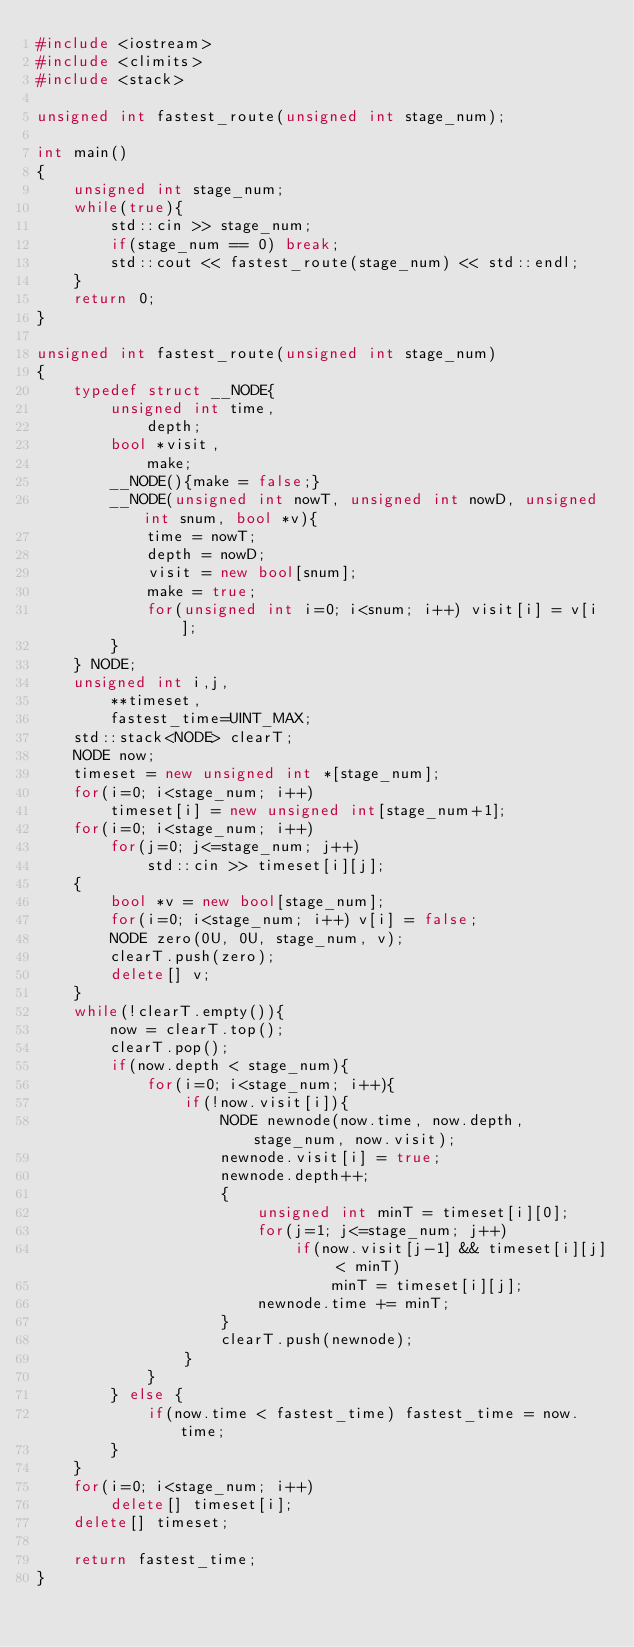Convert code to text. <code><loc_0><loc_0><loc_500><loc_500><_C++_>#include <iostream>
#include <climits>
#include <stack>

unsigned int fastest_route(unsigned int stage_num);

int main()
{
	unsigned int stage_num;
	while(true){
		std::cin >> stage_num;
		if(stage_num == 0) break;
		std::cout << fastest_route(stage_num) << std::endl;
	}
	return 0;
}

unsigned int fastest_route(unsigned int stage_num)
{
	typedef struct __NODE{
		unsigned int time,
			depth;
		bool *visit,
			make;
		__NODE(){make = false;}
		__NODE(unsigned int nowT, unsigned int nowD, unsigned int snum, bool *v){
			time = nowT;
			depth = nowD;
			visit = new bool[snum];
			make = true;
			for(unsigned int i=0; i<snum; i++) visit[i] = v[i];
		}
	} NODE;
	unsigned int i,j,
		**timeset,
		fastest_time=UINT_MAX;
	std::stack<NODE> clearT;
	NODE now;
	timeset = new unsigned int *[stage_num];
	for(i=0; i<stage_num; i++)
		timeset[i] = new unsigned int[stage_num+1];
	for(i=0; i<stage_num; i++)
		for(j=0; j<=stage_num; j++)
			std::cin >> timeset[i][j];
	{
		bool *v = new bool[stage_num];
		for(i=0; i<stage_num; i++) v[i] = false;
		NODE zero(0U, 0U, stage_num, v);
		clearT.push(zero);
		delete[] v;
	}
	while(!clearT.empty()){
		now = clearT.top();
		clearT.pop();
		if(now.depth < stage_num){
			for(i=0; i<stage_num; i++){
				if(!now.visit[i]){
					NODE newnode(now.time, now.depth, stage_num, now.visit);
					newnode.visit[i] = true;
					newnode.depth++;
					{
						unsigned int minT = timeset[i][0];
						for(j=1; j<=stage_num; j++)
							if(now.visit[j-1] && timeset[i][j] < minT)
								minT = timeset[i][j];
						newnode.time += minT;
					}
					clearT.push(newnode);
				}
			}
		} else {
			if(now.time < fastest_time) fastest_time = now.time;
		}
	}
	for(i=0; i<stage_num; i++)
		delete[] timeset[i];
	delete[] timeset;

	return fastest_time;
}</code> 